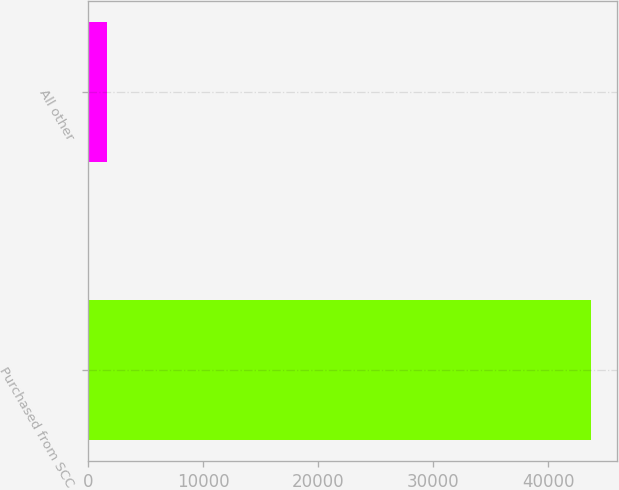Convert chart to OTSL. <chart><loc_0><loc_0><loc_500><loc_500><bar_chart><fcel>Purchased from SCC<fcel>All other<nl><fcel>43769<fcel>1632<nl></chart> 